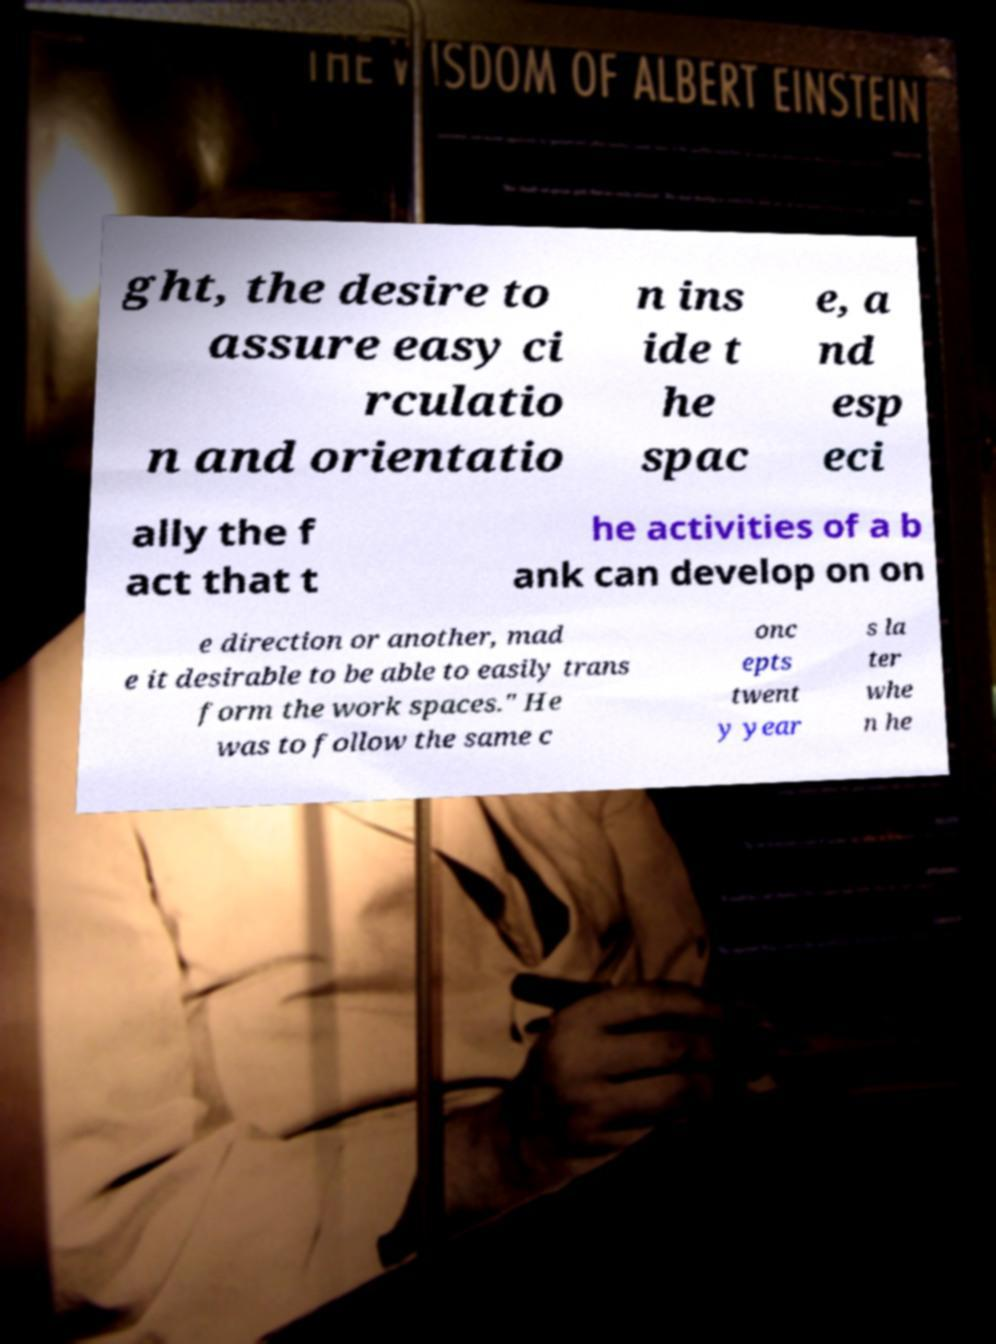Please read and relay the text visible in this image. What does it say? ght, the desire to assure easy ci rculatio n and orientatio n ins ide t he spac e, a nd esp eci ally the f act that t he activities of a b ank can develop on on e direction or another, mad e it desirable to be able to easily trans form the work spaces." He was to follow the same c onc epts twent y year s la ter whe n he 